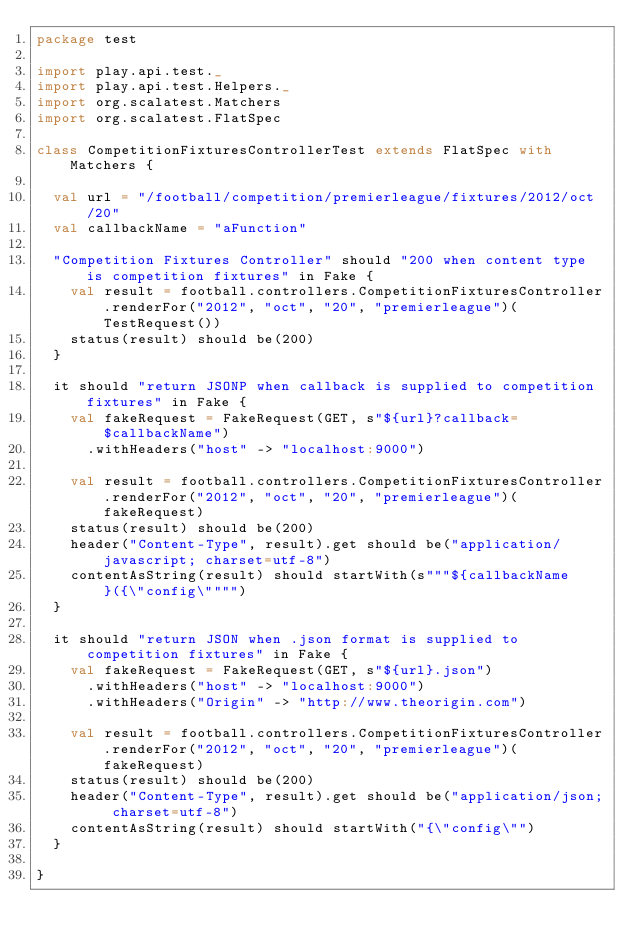Convert code to text. <code><loc_0><loc_0><loc_500><loc_500><_Scala_>package test

import play.api.test._
import play.api.test.Helpers._
import org.scalatest.Matchers
import org.scalatest.FlatSpec

class CompetitionFixturesControllerTest extends FlatSpec with Matchers {
  
  val url = "/football/competition/premierleague/fixtures/2012/oct/20"
  val callbackName = "aFunction"
  
  "Competition Fixtures Controller" should "200 when content type is competition fixtures" in Fake {
    val result = football.controllers.CompetitionFixturesController.renderFor("2012", "oct", "20", "premierleague")(TestRequest())
    status(result) should be(200)
  }

  it should "return JSONP when callback is supplied to competition fixtures" in Fake {
    val fakeRequest = FakeRequest(GET, s"${url}?callback=$callbackName")
      .withHeaders("host" -> "localhost:9000")
      
    val result = football.controllers.CompetitionFixturesController.renderFor("2012", "oct", "20", "premierleague")(fakeRequest)
    status(result) should be(200)
    header("Content-Type", result).get should be("application/javascript; charset=utf-8")
    contentAsString(result) should startWith(s"""${callbackName}({\"config\"""")
  }

  it should "return JSON when .json format is supplied to competition fixtures" in Fake {
    val fakeRequest = FakeRequest(GET, s"${url}.json")
      .withHeaders("host" -> "localhost:9000")
      .withHeaders("Origin" -> "http://www.theorigin.com")
        
    val result = football.controllers.CompetitionFixturesController.renderFor("2012", "oct", "20", "premierleague")(fakeRequest)
    status(result) should be(200)
    header("Content-Type", result).get should be("application/json; charset=utf-8")
    contentAsString(result) should startWith("{\"config\"")
  }
  
}</code> 